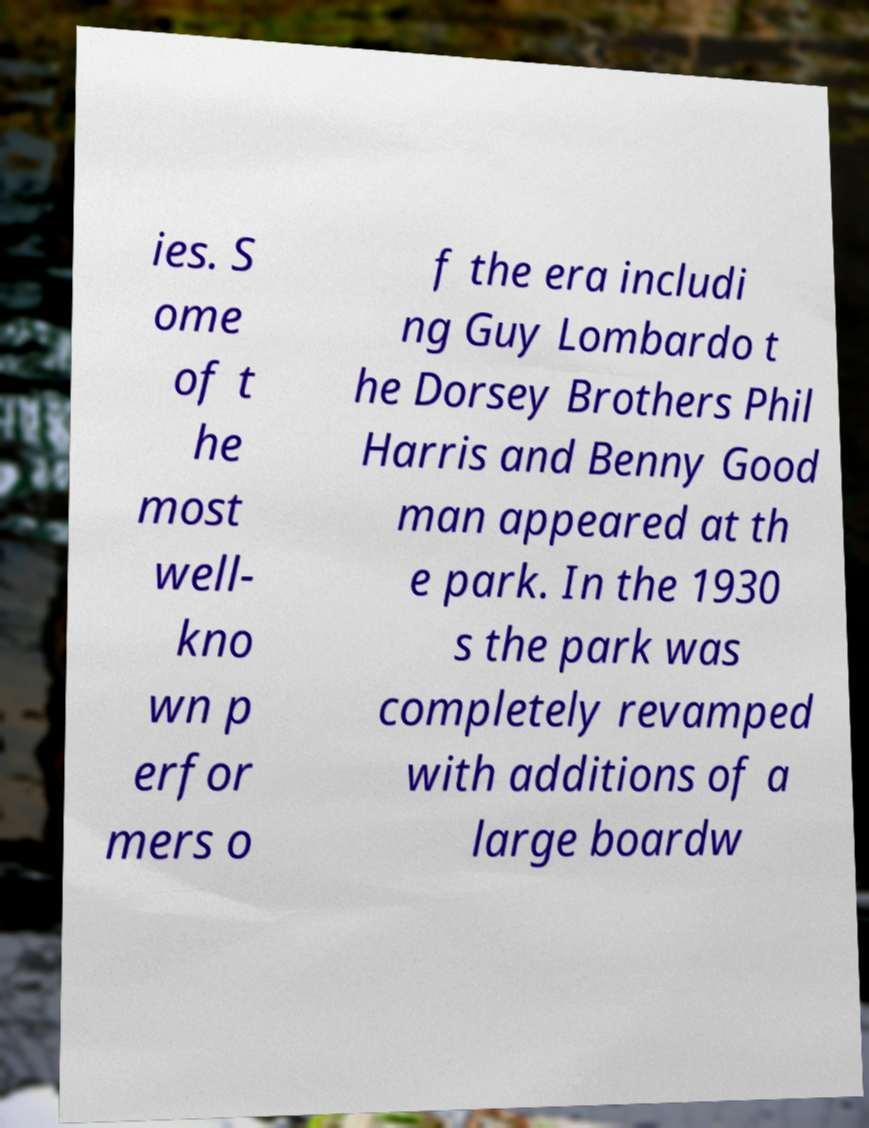I need the written content from this picture converted into text. Can you do that? ies. S ome of t he most well- kno wn p erfor mers o f the era includi ng Guy Lombardo t he Dorsey Brothers Phil Harris and Benny Good man appeared at th e park. In the 1930 s the park was completely revamped with additions of a large boardw 